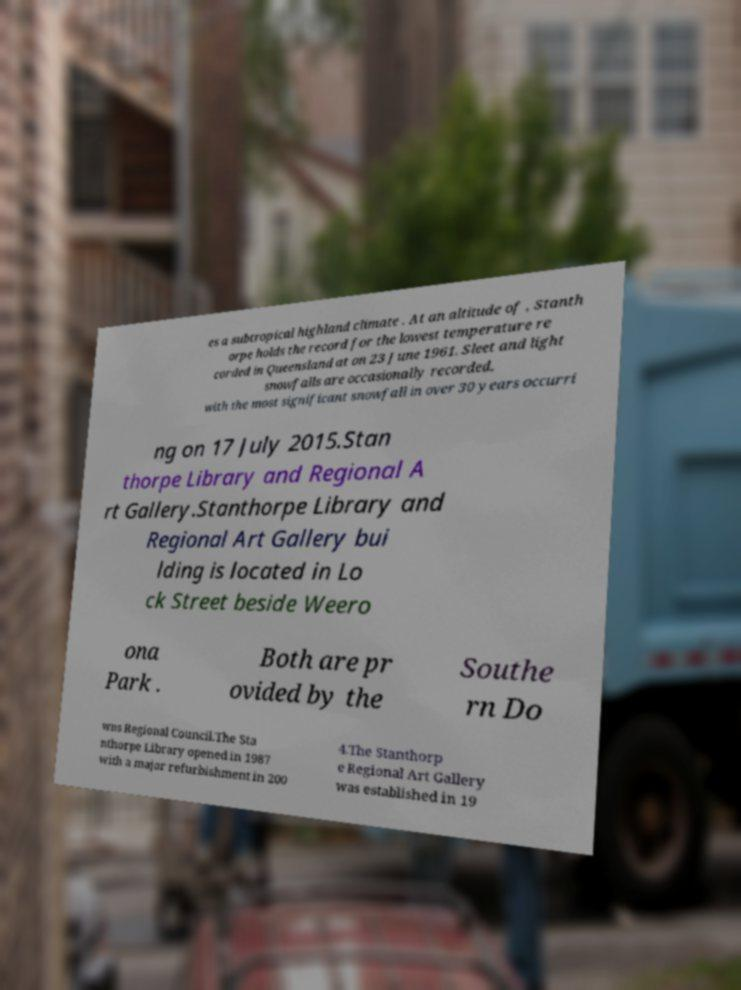Can you read and provide the text displayed in the image?This photo seems to have some interesting text. Can you extract and type it out for me? es a subtropical highland climate . At an altitude of , Stanth orpe holds the record for the lowest temperature re corded in Queensland at on 23 June 1961. Sleet and light snowfalls are occasionally recorded, with the most significant snowfall in over 30 years occurri ng on 17 July 2015.Stan thorpe Library and Regional A rt Gallery.Stanthorpe Library and Regional Art Gallery bui lding is located in Lo ck Street beside Weero ona Park . Both are pr ovided by the Southe rn Do wns Regional Council.The Sta nthorpe Library opened in 1987 with a major refurbishment in 200 4.The Stanthorp e Regional Art Gallery was established in 19 